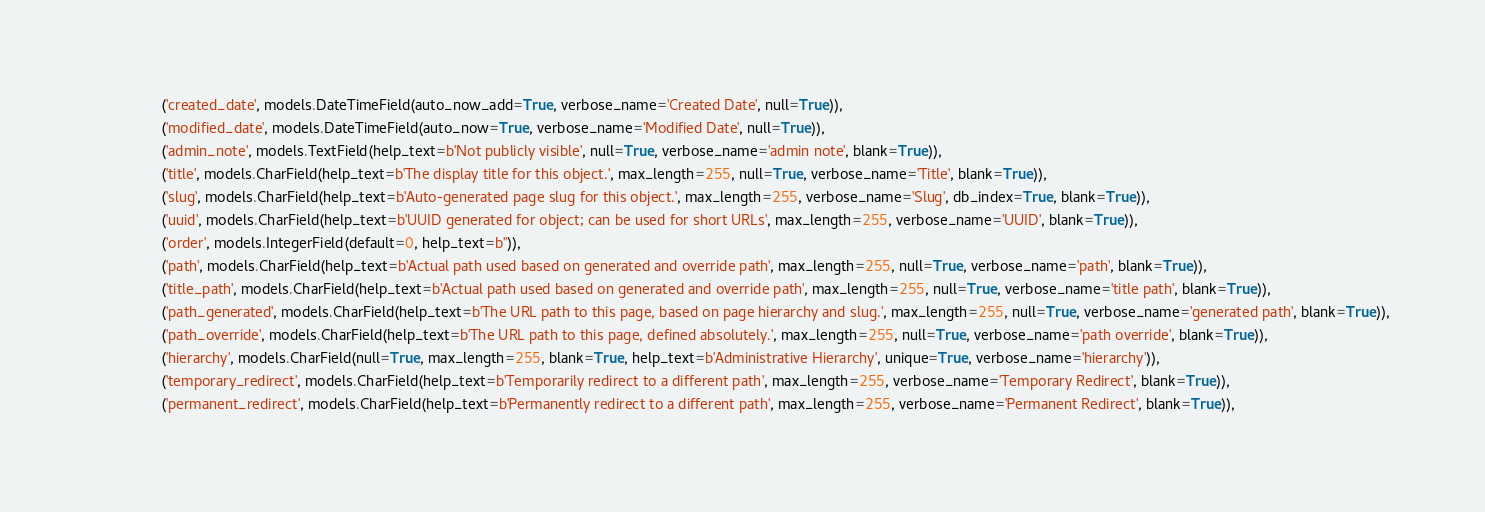<code> <loc_0><loc_0><loc_500><loc_500><_Python_>                ('created_date', models.DateTimeField(auto_now_add=True, verbose_name='Created Date', null=True)),
                ('modified_date', models.DateTimeField(auto_now=True, verbose_name='Modified Date', null=True)),
                ('admin_note', models.TextField(help_text=b'Not publicly visible', null=True, verbose_name='admin note', blank=True)),
                ('title', models.CharField(help_text=b'The display title for this object.', max_length=255, null=True, verbose_name='Title', blank=True)),
                ('slug', models.CharField(help_text=b'Auto-generated page slug for this object.', max_length=255, verbose_name='Slug', db_index=True, blank=True)),
                ('uuid', models.CharField(help_text=b'UUID generated for object; can be used for short URLs', max_length=255, verbose_name='UUID', blank=True)),
                ('order', models.IntegerField(default=0, help_text=b'')),
                ('path', models.CharField(help_text=b'Actual path used based on generated and override path', max_length=255, null=True, verbose_name='path', blank=True)),
                ('title_path', models.CharField(help_text=b'Actual path used based on generated and override path', max_length=255, null=True, verbose_name='title path', blank=True)),
                ('path_generated', models.CharField(help_text=b'The URL path to this page, based on page hierarchy and slug.', max_length=255, null=True, verbose_name='generated path', blank=True)),
                ('path_override', models.CharField(help_text=b'The URL path to this page, defined absolutely.', max_length=255, null=True, verbose_name='path override', blank=True)),
                ('hierarchy', models.CharField(null=True, max_length=255, blank=True, help_text=b'Administrative Hierarchy', unique=True, verbose_name='hierarchy')),
                ('temporary_redirect', models.CharField(help_text=b'Temporarily redirect to a different path', max_length=255, verbose_name='Temporary Redirect', blank=True)),
                ('permanent_redirect', models.CharField(help_text=b'Permanently redirect to a different path', max_length=255, verbose_name='Permanent Redirect', blank=True)),</code> 